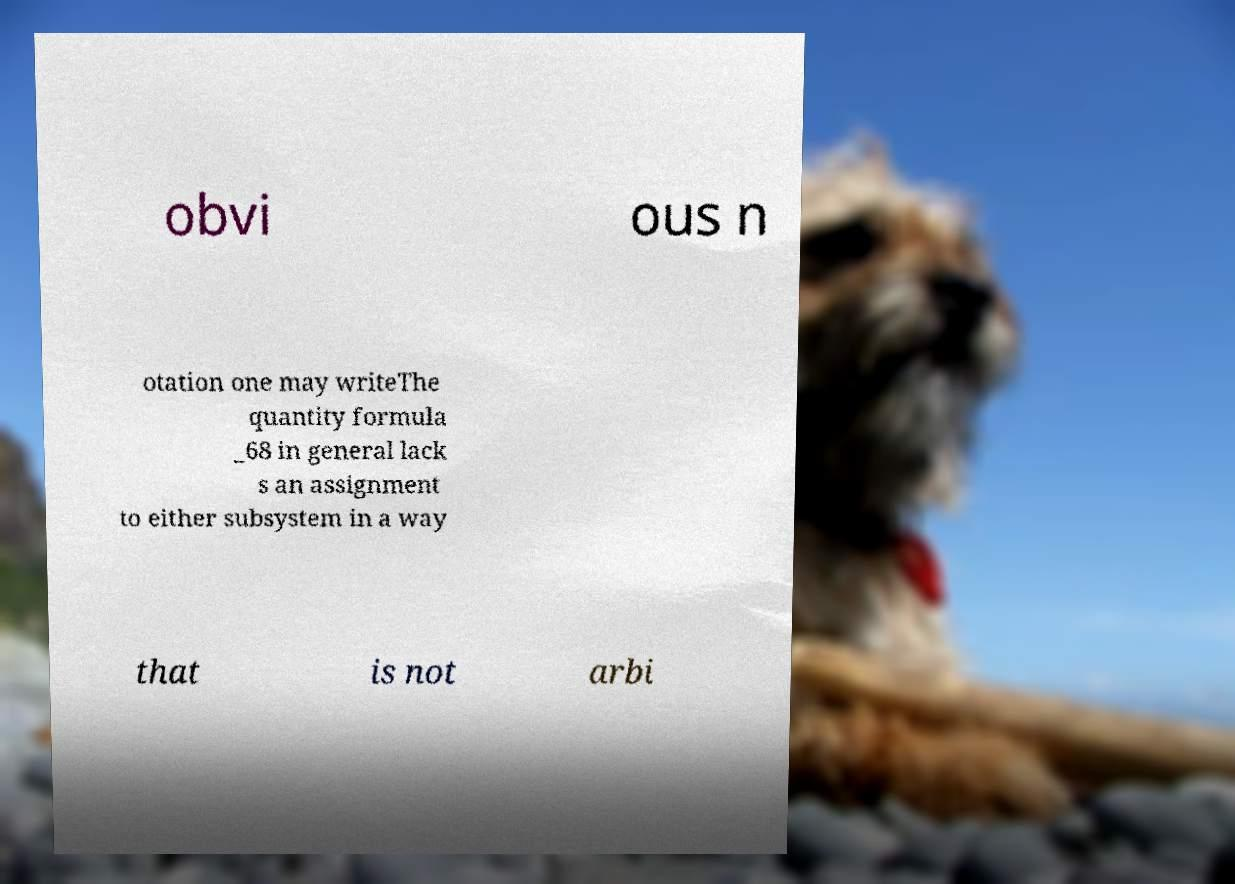For documentation purposes, I need the text within this image transcribed. Could you provide that? obvi ous n otation one may writeThe quantity formula _68 in general lack s an assignment to either subsystem in a way that is not arbi 